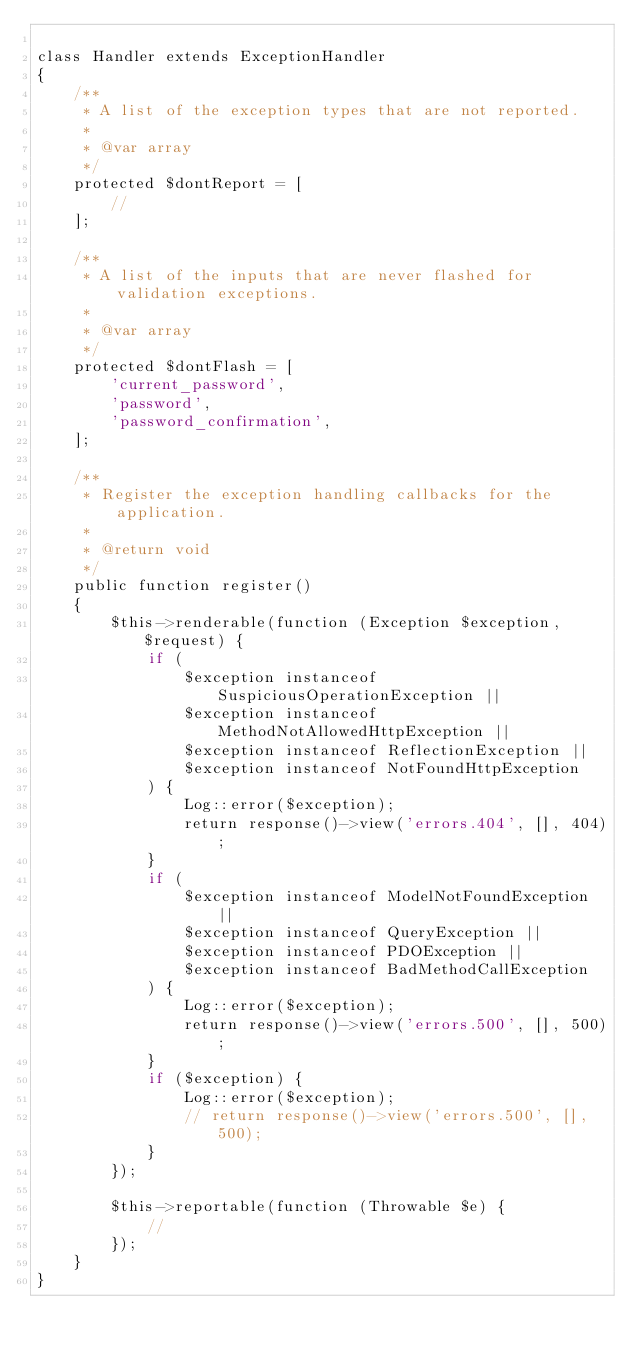Convert code to text. <code><loc_0><loc_0><loc_500><loc_500><_PHP_>
class Handler extends ExceptionHandler
{
    /**
     * A list of the exception types that are not reported.
     *
     * @var array
     */
    protected $dontReport = [
        //
    ];

    /**
     * A list of the inputs that are never flashed for validation exceptions.
     *
     * @var array
     */
    protected $dontFlash = [
        'current_password',
        'password',
        'password_confirmation',
    ];

    /**
     * Register the exception handling callbacks for the application.
     *
     * @return void
     */
    public function register()
    {
        $this->renderable(function (Exception $exception, $request) {
            if (
                $exception instanceof SuspiciousOperationException ||
                $exception instanceof MethodNotAllowedHttpException ||
                $exception instanceof ReflectionException ||
                $exception instanceof NotFoundHttpException
            ) {
                Log::error($exception);
                return response()->view('errors.404', [], 404);
            }
            if (
                $exception instanceof ModelNotFoundException ||
                $exception instanceof QueryException ||
                $exception instanceof PDOException ||
                $exception instanceof BadMethodCallException
            ) {
                Log::error($exception);
                return response()->view('errors.500', [], 500);
            }
            if ($exception) {
                Log::error($exception);
                // return response()->view('errors.500', [], 500);
            }
        });

        $this->reportable(function (Throwable $e) {
            //
        });
    }
}
</code> 